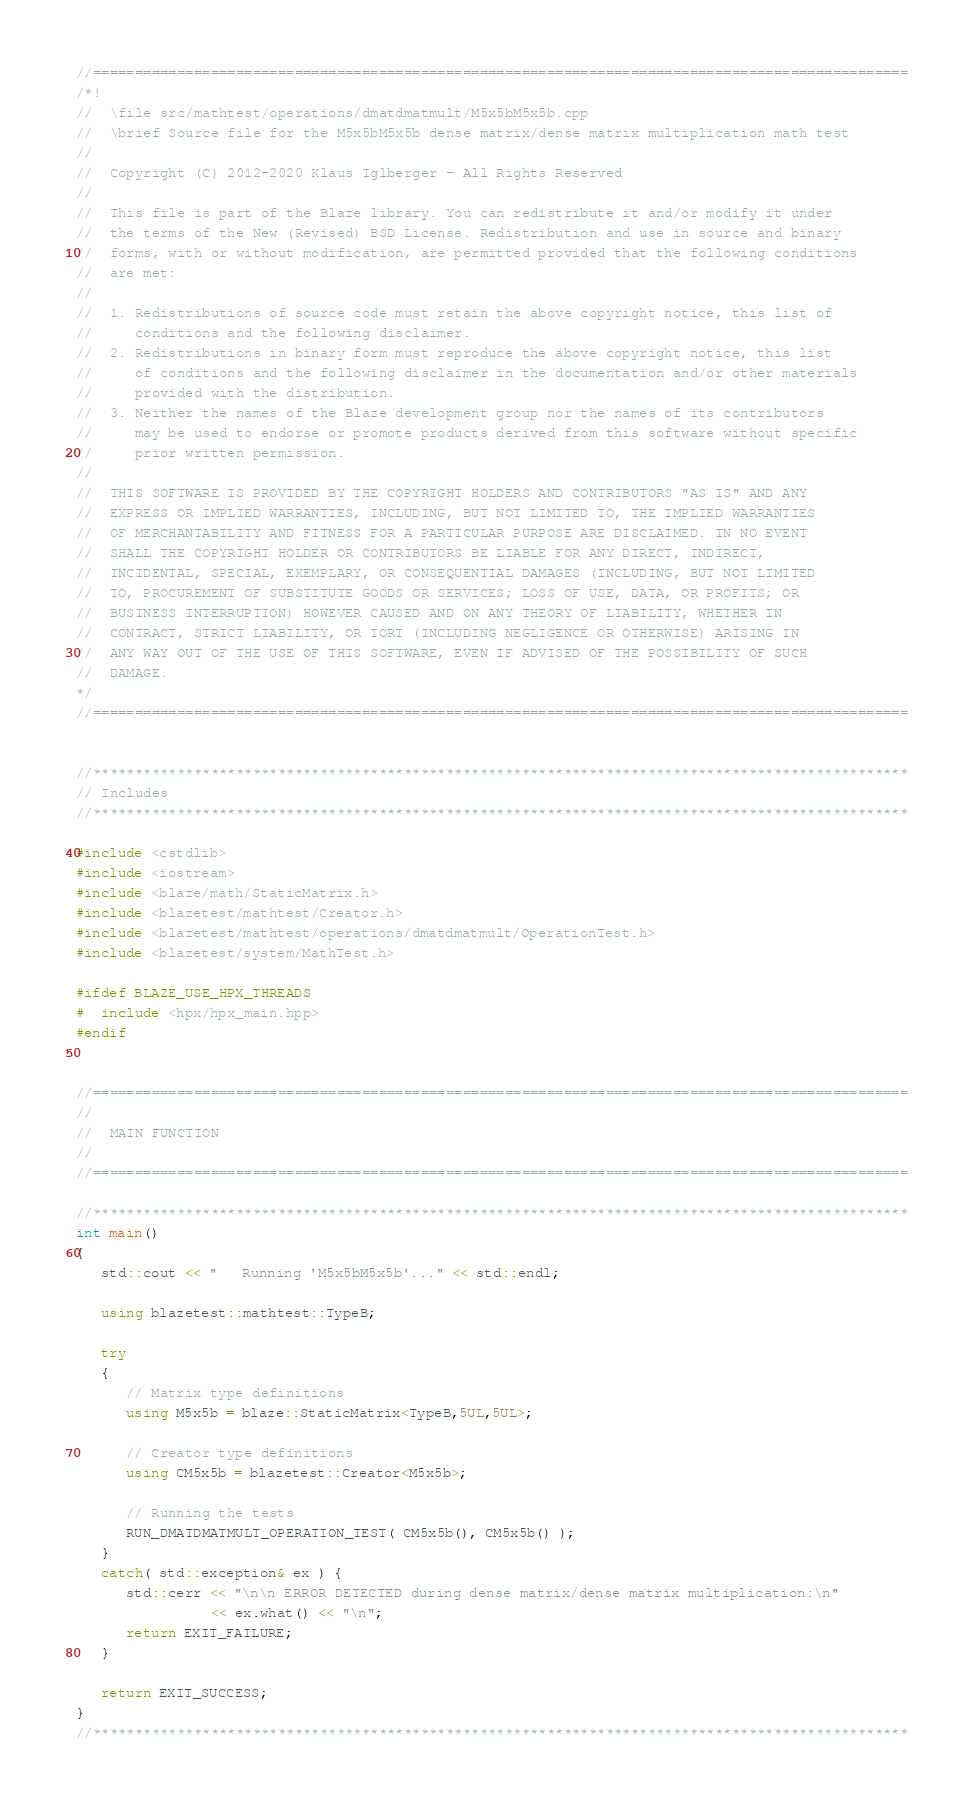Convert code to text. <code><loc_0><loc_0><loc_500><loc_500><_C++_>//=================================================================================================
/*!
//  \file src/mathtest/operations/dmatdmatmult/M5x5bM5x5b.cpp
//  \brief Source file for the M5x5bM5x5b dense matrix/dense matrix multiplication math test
//
//  Copyright (C) 2012-2020 Klaus Iglberger - All Rights Reserved
//
//  This file is part of the Blaze library. You can redistribute it and/or modify it under
//  the terms of the New (Revised) BSD License. Redistribution and use in source and binary
//  forms, with or without modification, are permitted provided that the following conditions
//  are met:
//
//  1. Redistributions of source code must retain the above copyright notice, this list of
//     conditions and the following disclaimer.
//  2. Redistributions in binary form must reproduce the above copyright notice, this list
//     of conditions and the following disclaimer in the documentation and/or other materials
//     provided with the distribution.
//  3. Neither the names of the Blaze development group nor the names of its contributors
//     may be used to endorse or promote products derived from this software without specific
//     prior written permission.
//
//  THIS SOFTWARE IS PROVIDED BY THE COPYRIGHT HOLDERS AND CONTRIBUTORS "AS IS" AND ANY
//  EXPRESS OR IMPLIED WARRANTIES, INCLUDING, BUT NOT LIMITED TO, THE IMPLIED WARRANTIES
//  OF MERCHANTABILITY AND FITNESS FOR A PARTICULAR PURPOSE ARE DISCLAIMED. IN NO EVENT
//  SHALL THE COPYRIGHT HOLDER OR CONTRIBUTORS BE LIABLE FOR ANY DIRECT, INDIRECT,
//  INCIDENTAL, SPECIAL, EXEMPLARY, OR CONSEQUENTIAL DAMAGES (INCLUDING, BUT NOT LIMITED
//  TO, PROCUREMENT OF SUBSTITUTE GOODS OR SERVICES; LOSS OF USE, DATA, OR PROFITS; OR
//  BUSINESS INTERRUPTION) HOWEVER CAUSED AND ON ANY THEORY OF LIABILITY, WHETHER IN
//  CONTRACT, STRICT LIABILITY, OR TORT (INCLUDING NEGLIGENCE OR OTHERWISE) ARISING IN
//  ANY WAY OUT OF THE USE OF THIS SOFTWARE, EVEN IF ADVISED OF THE POSSIBILITY OF SUCH
//  DAMAGE.
*/
//=================================================================================================


//*************************************************************************************************
// Includes
//*************************************************************************************************

#include <cstdlib>
#include <iostream>
#include <blaze/math/StaticMatrix.h>
#include <blazetest/mathtest/Creator.h>
#include <blazetest/mathtest/operations/dmatdmatmult/OperationTest.h>
#include <blazetest/system/MathTest.h>

#ifdef BLAZE_USE_HPX_THREADS
#  include <hpx/hpx_main.hpp>
#endif


//=================================================================================================
//
//  MAIN FUNCTION
//
//=================================================================================================

//*************************************************************************************************
int main()
{
   std::cout << "   Running 'M5x5bM5x5b'..." << std::endl;

   using blazetest::mathtest::TypeB;

   try
   {
      // Matrix type definitions
      using M5x5b = blaze::StaticMatrix<TypeB,5UL,5UL>;

      // Creator type definitions
      using CM5x5b = blazetest::Creator<M5x5b>;

      // Running the tests
      RUN_DMATDMATMULT_OPERATION_TEST( CM5x5b(), CM5x5b() );
   }
   catch( std::exception& ex ) {
      std::cerr << "\n\n ERROR DETECTED during dense matrix/dense matrix multiplication:\n"
                << ex.what() << "\n";
      return EXIT_FAILURE;
   }

   return EXIT_SUCCESS;
}
//*************************************************************************************************
</code> 